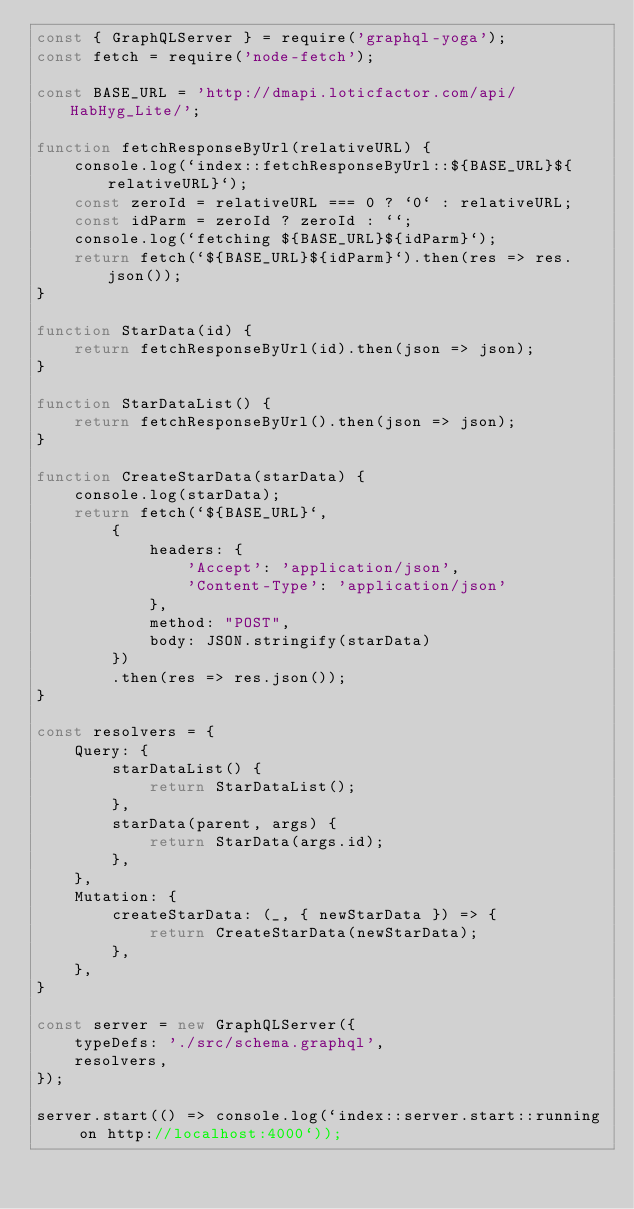<code> <loc_0><loc_0><loc_500><loc_500><_JavaScript_>const { GraphQLServer } = require('graphql-yoga');
const fetch = require('node-fetch');

const BASE_URL = 'http://dmapi.loticfactor.com/api/HabHyg_Lite/';

function fetchResponseByUrl(relativeURL) {
    console.log(`index::fetchResponseByUrl::${BASE_URL}${relativeURL}`);
    const zeroId = relativeURL === 0 ? `0` : relativeURL;
    const idParm = zeroId ? zeroId : ``;
    console.log(`fetching ${BASE_URL}${idParm}`);
    return fetch(`${BASE_URL}${idParm}`).then(res => res.json());
}

function StarData(id) {
    return fetchResponseByUrl(id).then(json => json);
}

function StarDataList() {
    return fetchResponseByUrl().then(json => json);
}

function CreateStarData(starData) {
    console.log(starData);
    return fetch(`${BASE_URL}`,
        {
            headers: {
                'Accept': 'application/json',
                'Content-Type': 'application/json'
            },
            method: "POST",
            body: JSON.stringify(starData)
        })
        .then(res => res.json());
}

const resolvers = {
    Query: {
        starDataList() {
            return StarDataList();
        },
        starData(parent, args) {
            return StarData(args.id);
        },
    },
    Mutation: {
        createStarData: (_, { newStarData }) => {
            return CreateStarData(newStarData);
        },
    },
}

const server = new GraphQLServer({
    typeDefs: './src/schema.graphql',
    resolvers,
});

server.start(() => console.log(`index::server.start::running on http://localhost:4000`));</code> 